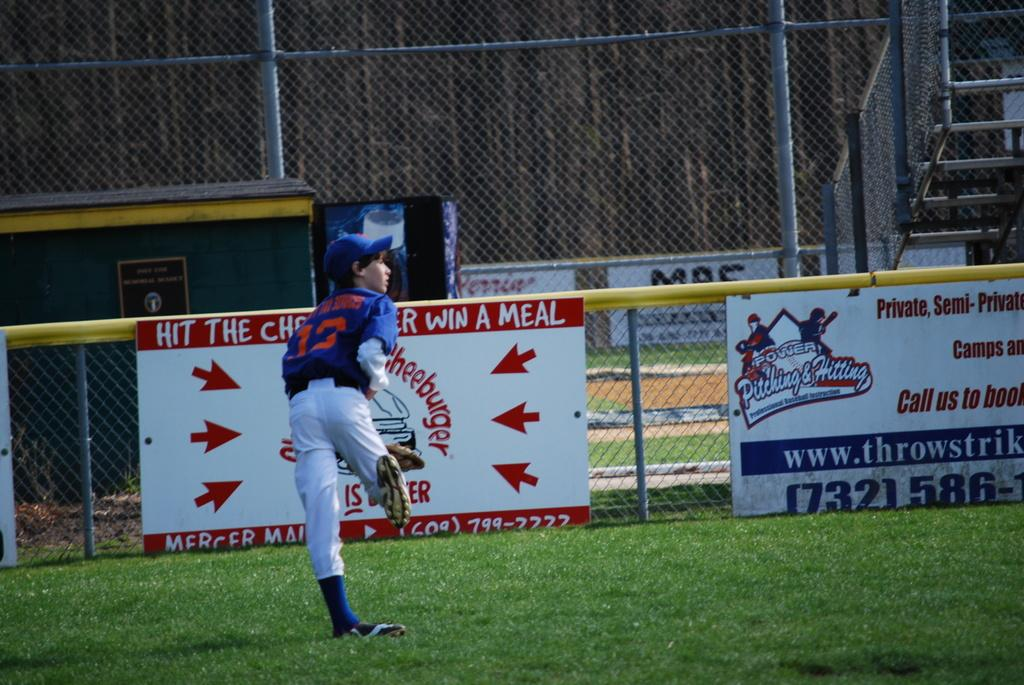<image>
Render a clear and concise summary of the photo. A baseball player stand on a field in front of a fence with an advertisement for Power Pitching & Hitting. 